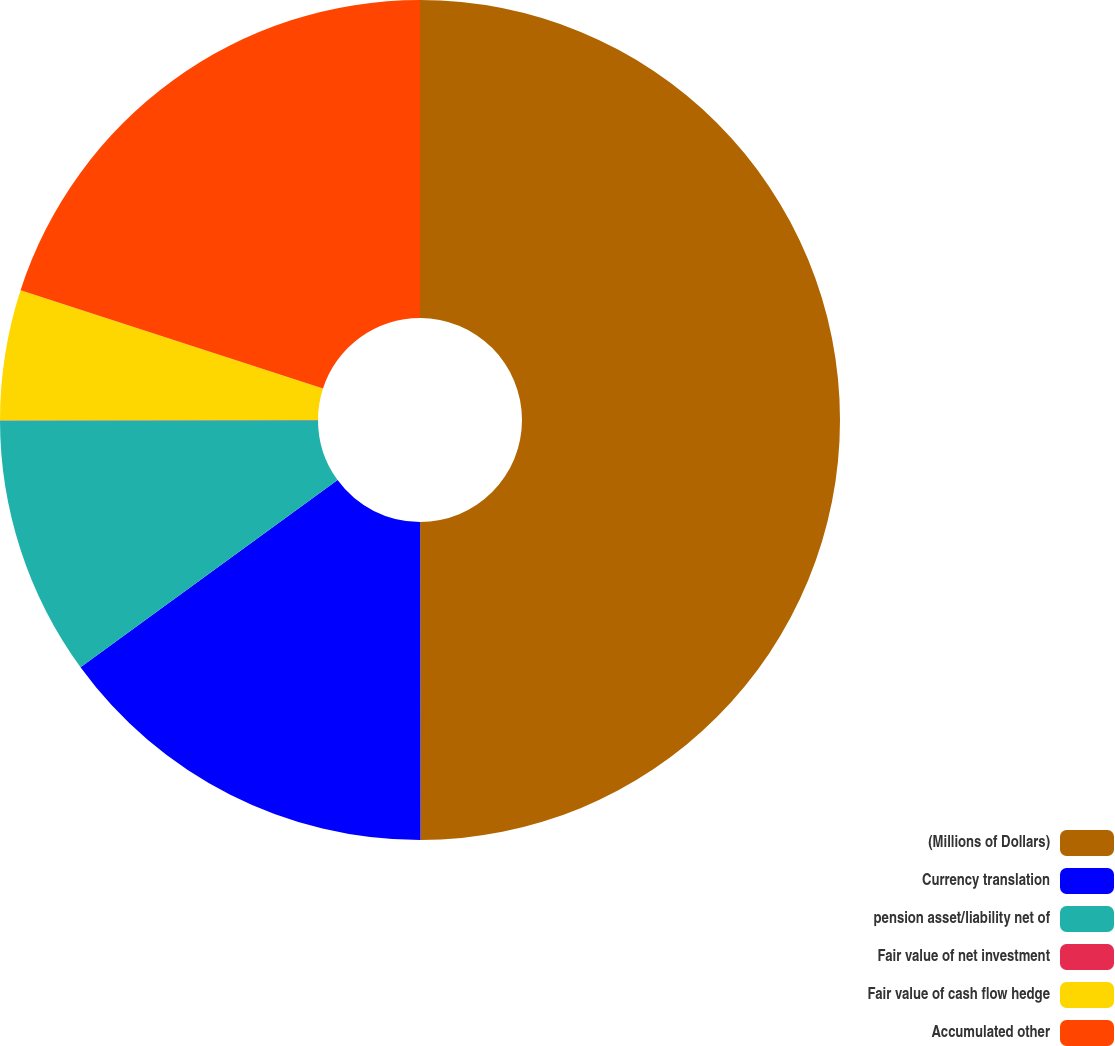<chart> <loc_0><loc_0><loc_500><loc_500><pie_chart><fcel>(Millions of Dollars)<fcel>Currency translation<fcel>pension asset/liability net of<fcel>Fair value of net investment<fcel>Fair value of cash flow hedge<fcel>Accumulated other<nl><fcel>49.98%<fcel>15.0%<fcel>10.0%<fcel>0.01%<fcel>5.01%<fcel>20.0%<nl></chart> 